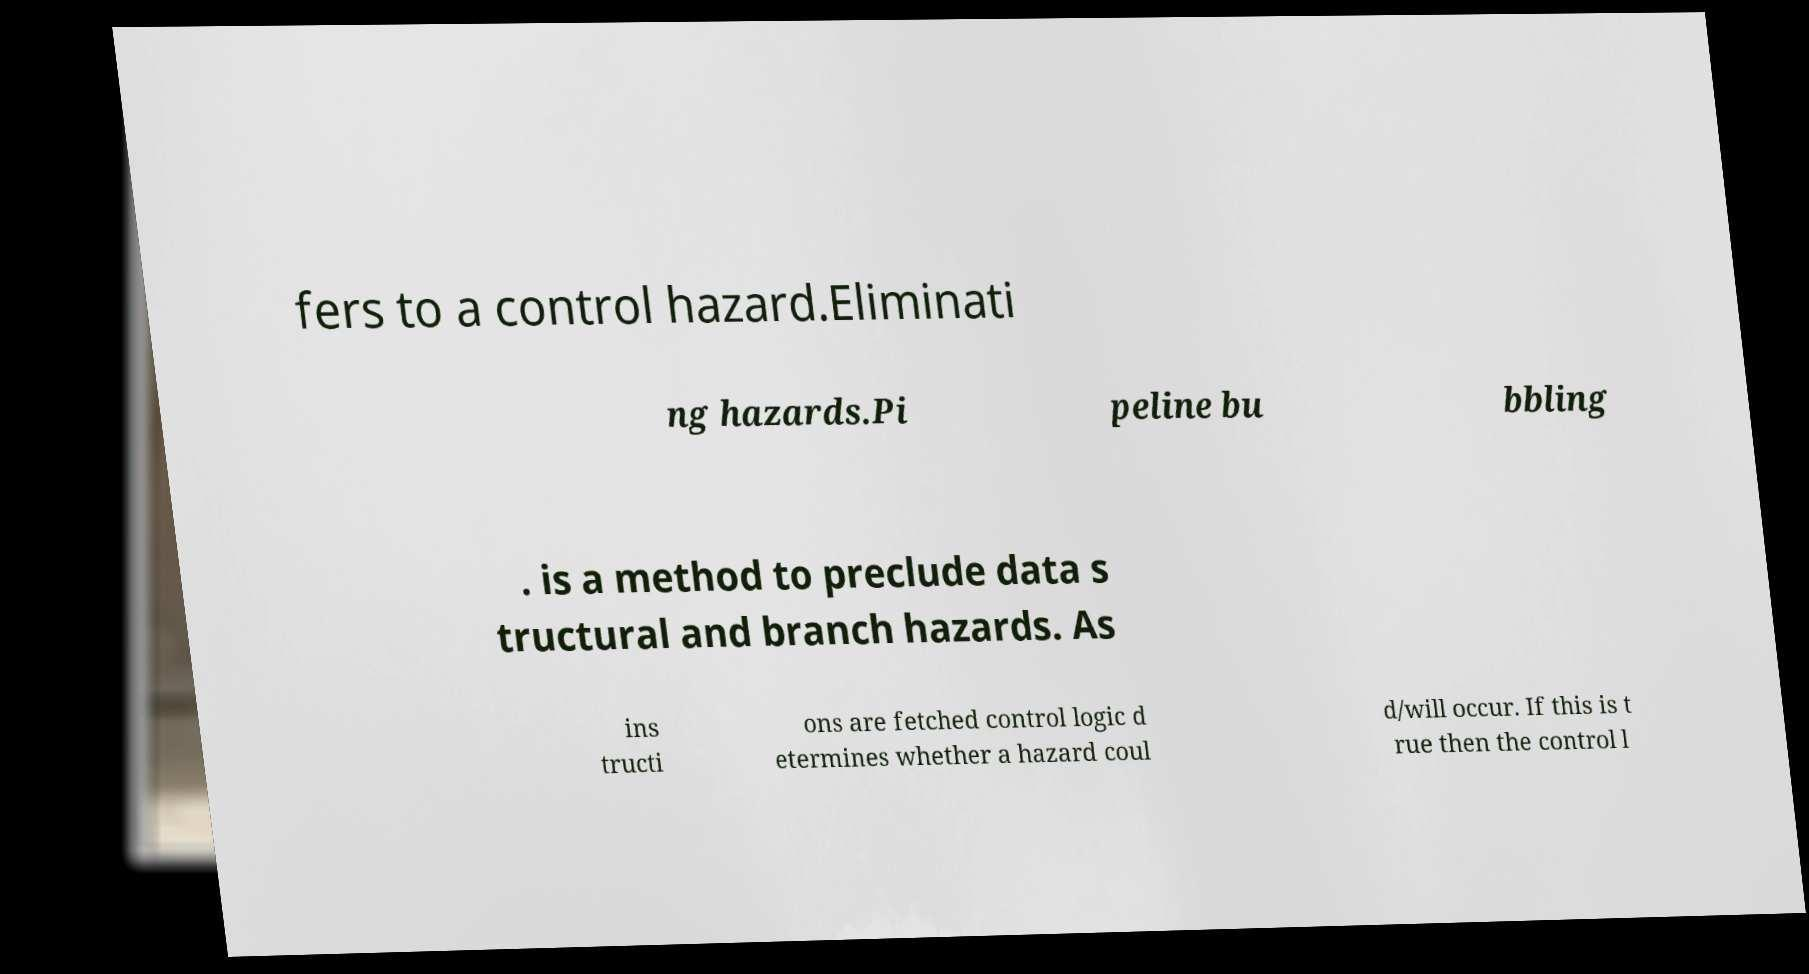Could you assist in decoding the text presented in this image and type it out clearly? fers to a control hazard.Eliminati ng hazards.Pi peline bu bbling . is a method to preclude data s tructural and branch hazards. As ins tructi ons are fetched control logic d etermines whether a hazard coul d/will occur. If this is t rue then the control l 